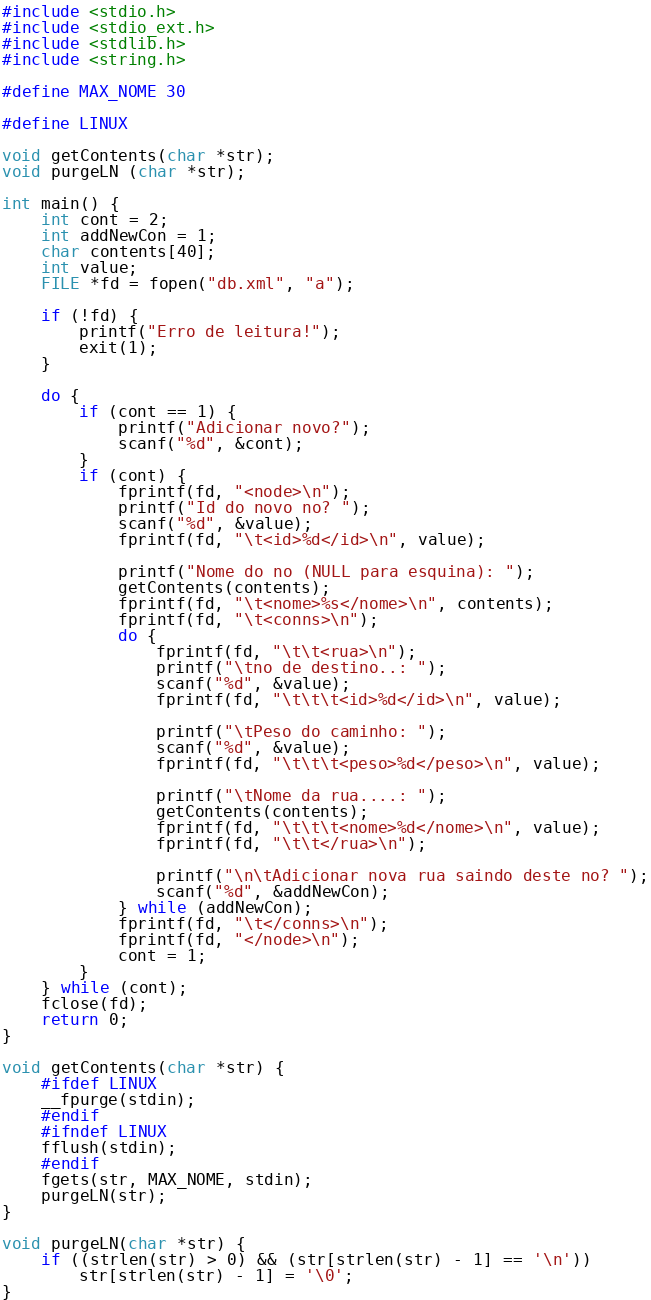Convert code to text. <code><loc_0><loc_0><loc_500><loc_500><_C++_>#include <stdio.h>
#include <stdio_ext.h>
#include <stdlib.h>
#include <string.h>

#define MAX_NOME 30

#define LINUX

void getContents(char *str);
void purgeLN (char *str);

int main() {
	int cont = 2;
	int addNewCon = 1;
	char contents[40];
	int value;
	FILE *fd = fopen("db.xml", "a");
	
	if (!fd) {
		printf("Erro de leitura!");
		exit(1);
	}
	
	do {
		if (cont == 1) {
			printf("Adicionar novo?");
			scanf("%d", &cont);
		}
		if (cont) {
			fprintf(fd, "<node>\n");
			printf("Id do novo no? ");
			scanf("%d", &value);
			fprintf(fd, "\t<id>%d</id>\n", value);
			
			printf("Nome do no (NULL para esquina): ");
			getContents(contents);
			fprintf(fd, "\t<nome>%s</nome>\n", contents);
			fprintf(fd, "\t<conns>\n");
			do {
				fprintf(fd, "\t\t<rua>\n");
				printf("\tno de destino..: ");
				scanf("%d", &value);
				fprintf(fd, "\t\t\t<id>%d</id>\n", value);
				
				printf("\tPeso do caminho: ");
				scanf("%d", &value);
				fprintf(fd, "\t\t\t<peso>%d</peso>\n", value);
				
				printf("\tNome da rua....: ");
				getContents(contents);
				fprintf(fd, "\t\t\t<nome>%d</nome>\n", value);
				fprintf(fd, "\t\t</rua>\n");
				
				printf("\n\tAdicionar nova rua saindo deste no? ");
				scanf("%d", &addNewCon);
			} while (addNewCon);
			fprintf(fd, "\t</conns>\n");
			fprintf(fd, "</node>\n");
			cont = 1;
		}
	} while (cont);
	fclose(fd);
	return 0;
}

void getContents(char *str) {
	#ifdef LINUX
	__fpurge(stdin);
	#endif
	#ifndef LINUX
	fflush(stdin);
	#endif
	fgets(str, MAX_NOME, stdin);
	purgeLN(str);
}

void purgeLN(char *str) {
	if ((strlen(str) > 0) && (str[strlen(str) - 1] == '\n'))
        str[strlen(str) - 1] = '\0';
}
</code> 